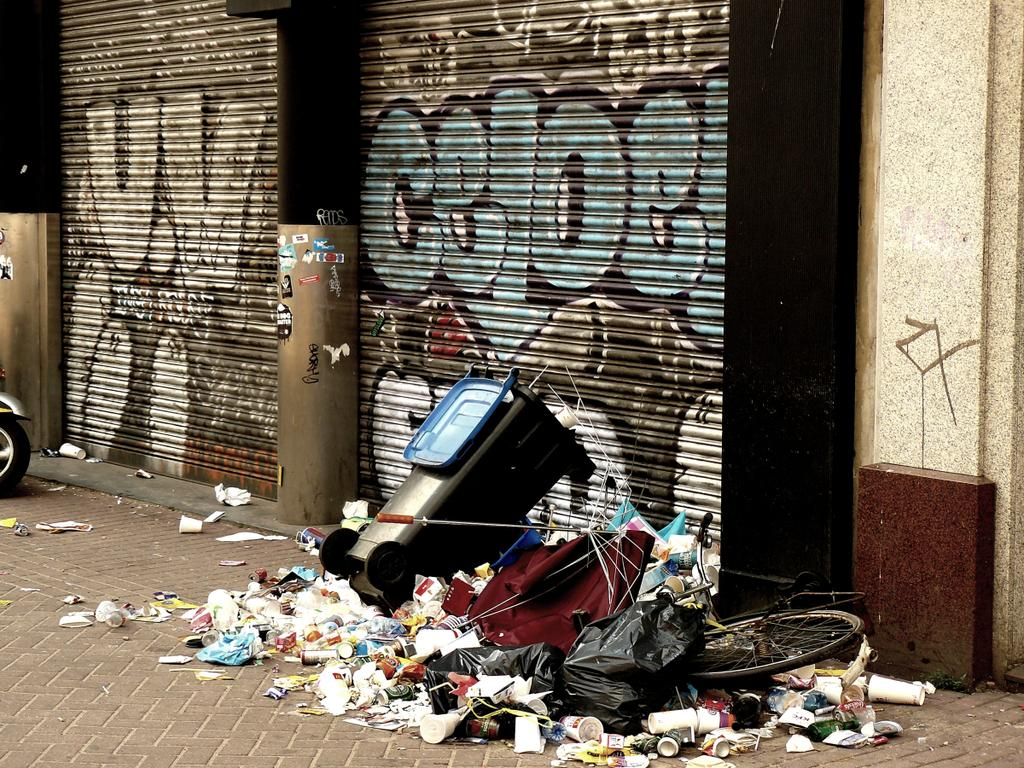<image>
Provide a brief description of the given image. a trash bin has been dumped under a tag on the wall that says Celoe 